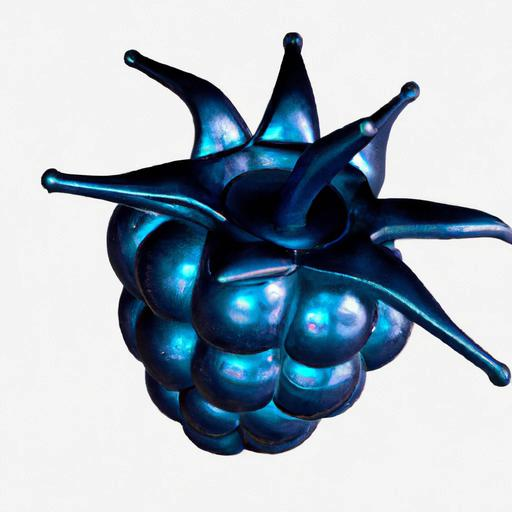What colors are predominant in this image? The predominant colors in this image are various shades of blue, ranging from light to dark, with an iridescent quality that gives the object a vibrant, metallic sheen. 